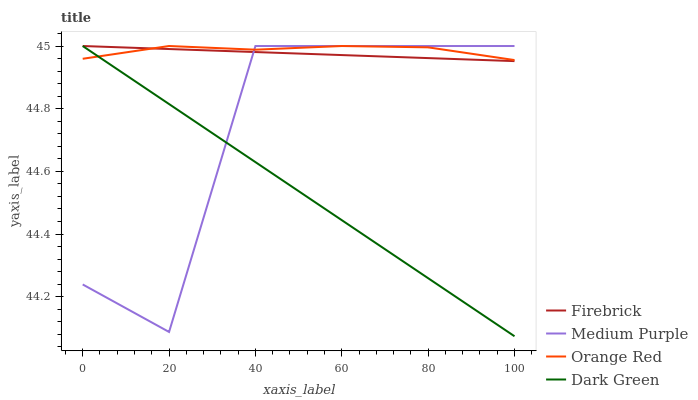Does Firebrick have the minimum area under the curve?
Answer yes or no. No. Does Firebrick have the maximum area under the curve?
Answer yes or no. No. Is Orange Red the smoothest?
Answer yes or no. No. Is Orange Red the roughest?
Answer yes or no. No. Does Firebrick have the lowest value?
Answer yes or no. No. 